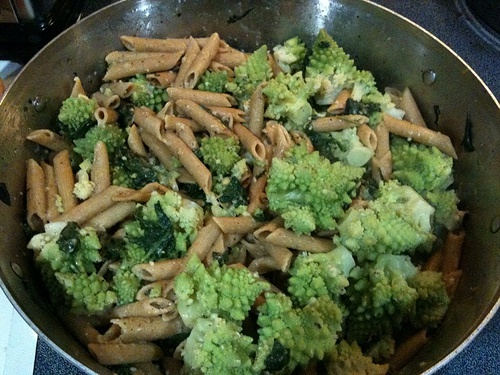Describe the objects in this image and their specific colors. I can see bowl in black, darkgreen, olive, and gray tones, broccoli in black, green, darkgreen, and lightgreen tones, broccoli in black, darkgreen, and green tones, broccoli in black, green, and darkgreen tones, and broccoli in black, olive, darkgreen, and darkgray tones in this image. 